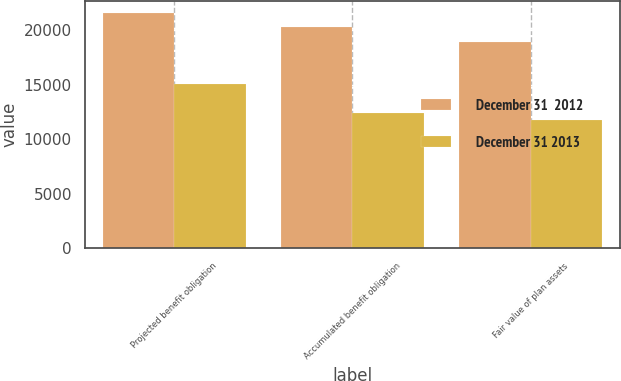<chart> <loc_0><loc_0><loc_500><loc_500><stacked_bar_chart><ecel><fcel>Projected benefit obligation<fcel>Accumulated benefit obligation<fcel>Fair value of plan assets<nl><fcel>December 31  2012<fcel>21579<fcel>20302<fcel>18934<nl><fcel>December 31 2013<fcel>15067<fcel>12396<fcel>11702<nl></chart> 